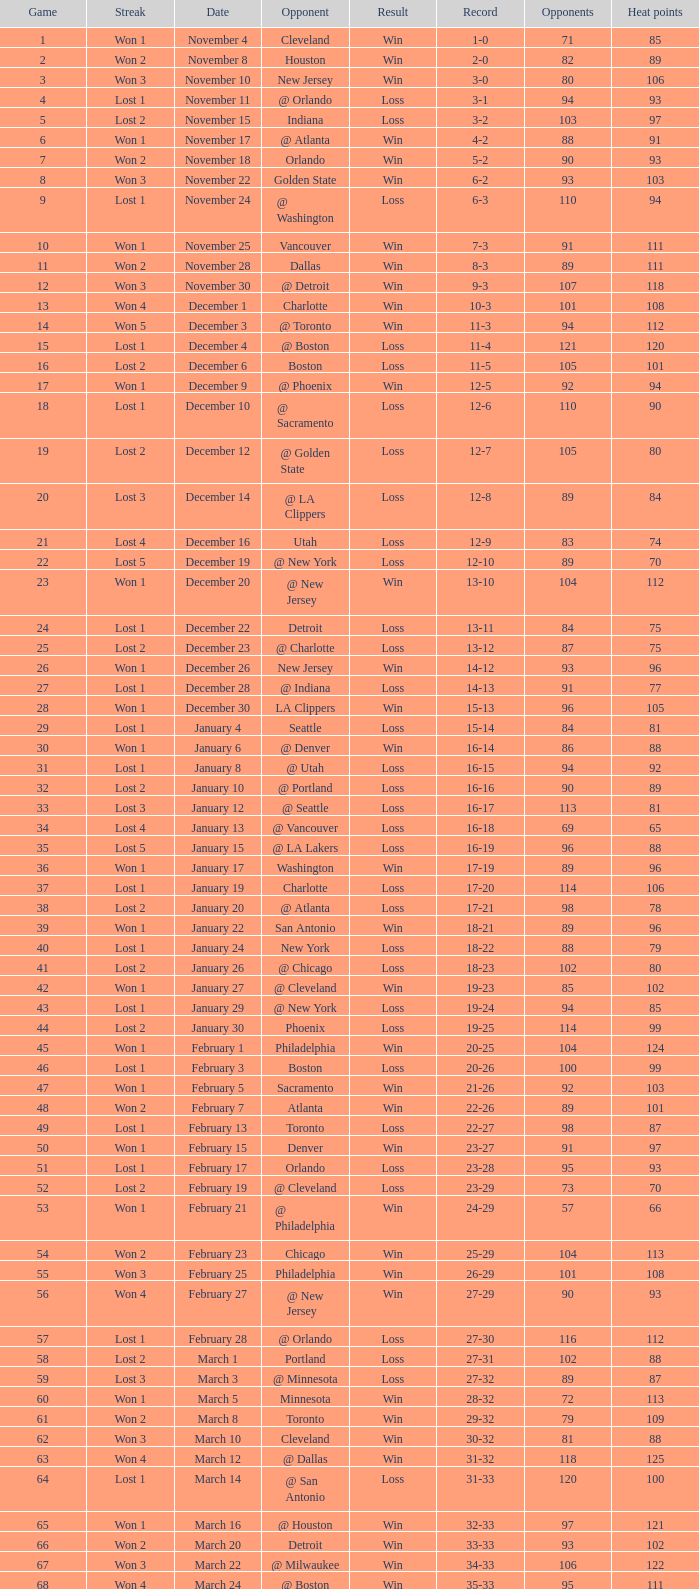What is Result, when Date is "December 12"? Loss. 